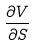Convert formula to latex. <formula><loc_0><loc_0><loc_500><loc_500>\frac { \partial V } { \partial S }</formula> 